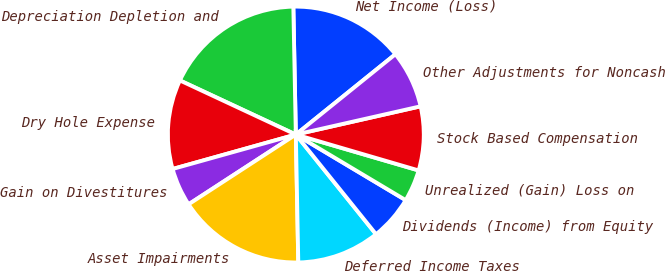Convert chart. <chart><loc_0><loc_0><loc_500><loc_500><pie_chart><fcel>Net Income (Loss)<fcel>Depreciation Depletion and<fcel>Dry Hole Expense<fcel>Gain on Divestitures<fcel>Asset Impairments<fcel>Deferred Income Taxes<fcel>Dividends (Income) from Equity<fcel>Unrealized (Gain) Loss on<fcel>Stock Based Compensation<fcel>Other Adjustments for Noncash<nl><fcel>14.51%<fcel>17.74%<fcel>11.29%<fcel>4.84%<fcel>16.13%<fcel>10.48%<fcel>5.65%<fcel>4.04%<fcel>8.07%<fcel>7.26%<nl></chart> 